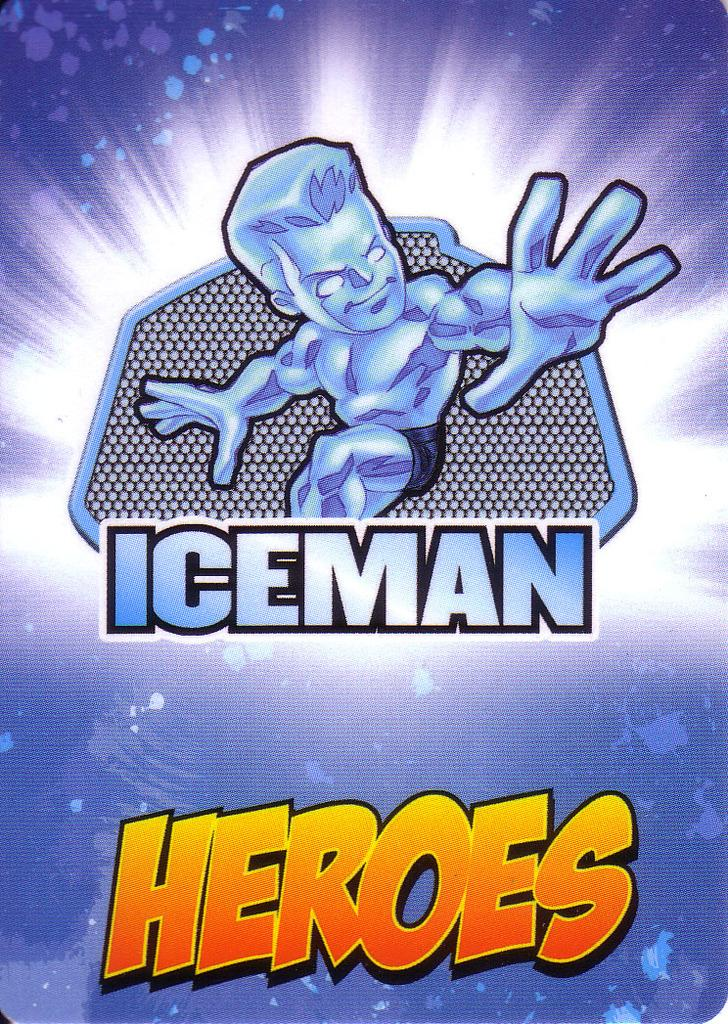<image>
Share a concise interpretation of the image provided. A poster with a cartoon man that says Iceman Heroes. 